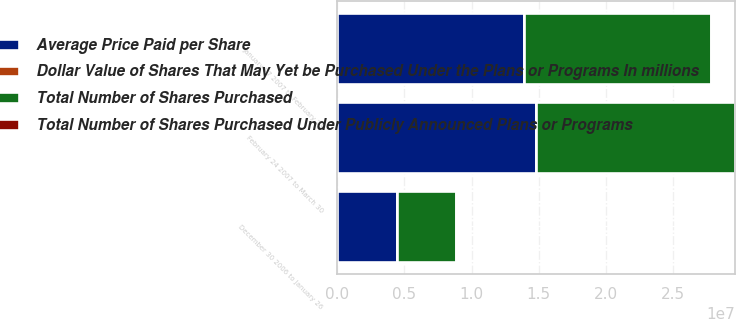<chart> <loc_0><loc_0><loc_500><loc_500><stacked_bar_chart><ecel><fcel>December 30 2006 to January 26<fcel>January 27 2007 to February 23<fcel>February 24 2007 to March 30<nl><fcel>Average Price Paid per Share<fcel>4.41707e+06<fcel>1.39105e+07<fcel>1.48084e+07<nl><fcel>Total Number of Shares Purchased Under Publicly Announced Plans or Programs<fcel>21.51<fcel>17.97<fcel>16.88<nl><fcel>Total Number of Shares Purchased<fcel>4.41707e+06<fcel>1.39105e+07<fcel>1.48084e+07<nl><fcel>Dollar Value of Shares That May Yet be Purchased Under the Plans or Programs In millions<fcel>1000<fcel>750<fcel>500<nl></chart> 